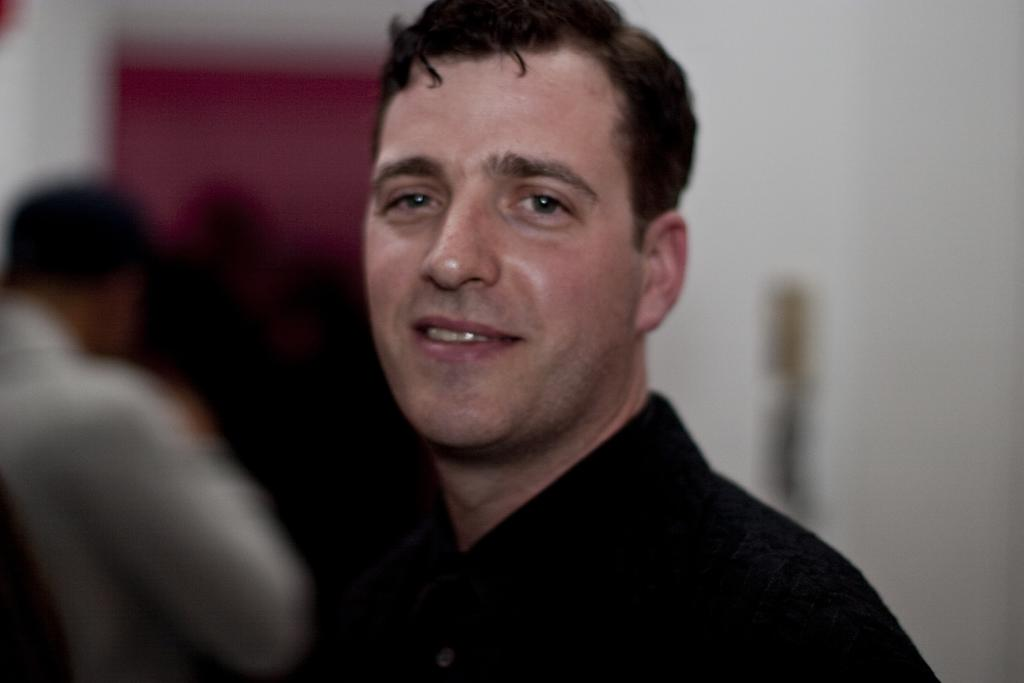Who is present in the image? There is a man in the picture. What is the man doing in the image? The man is looking to his side. What is the man wearing in the image? The man is wearing a black color shirt. What type of eggs can be seen in the man's hand in the image? There are no eggs present in the image; the man is not holding anything in his hand. 